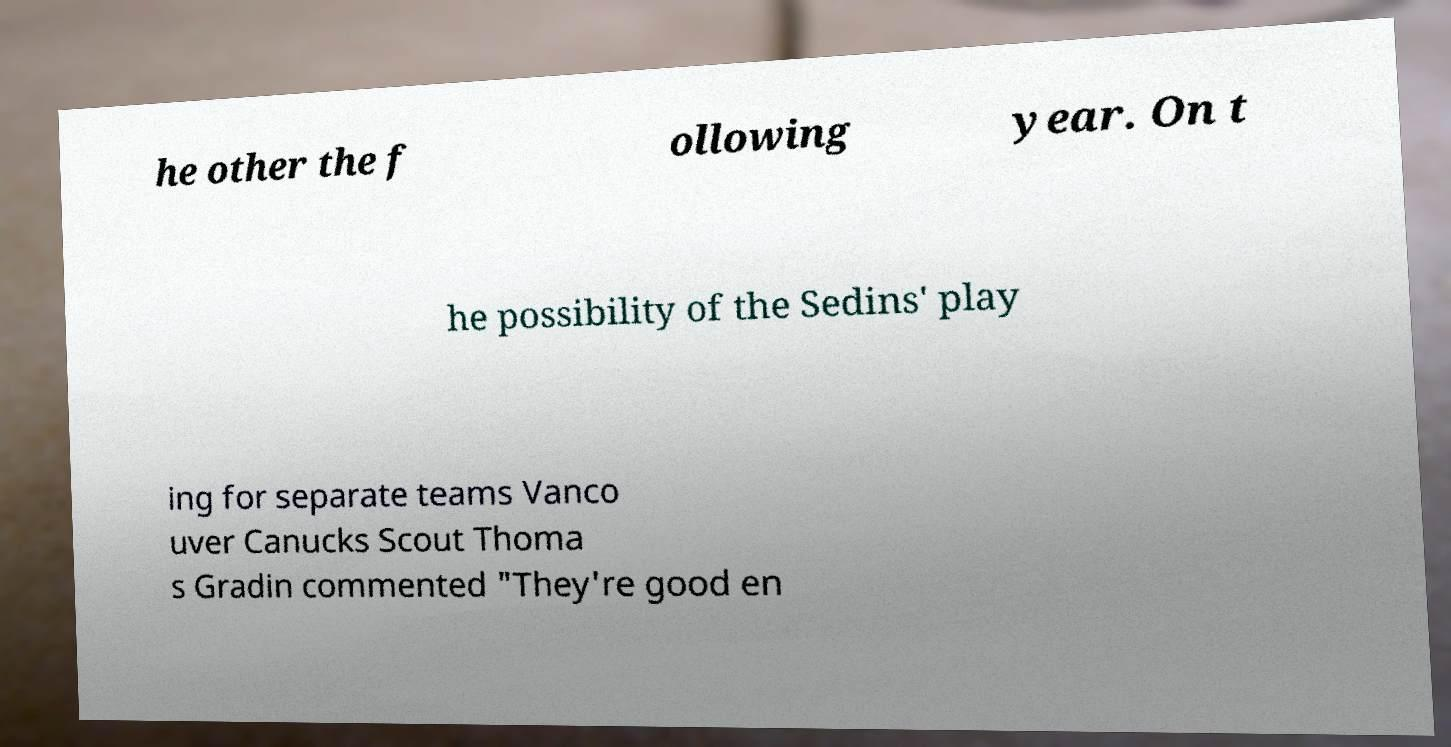Please read and relay the text visible in this image. What does it say? he other the f ollowing year. On t he possibility of the Sedins' play ing for separate teams Vanco uver Canucks Scout Thoma s Gradin commented "They're good en 